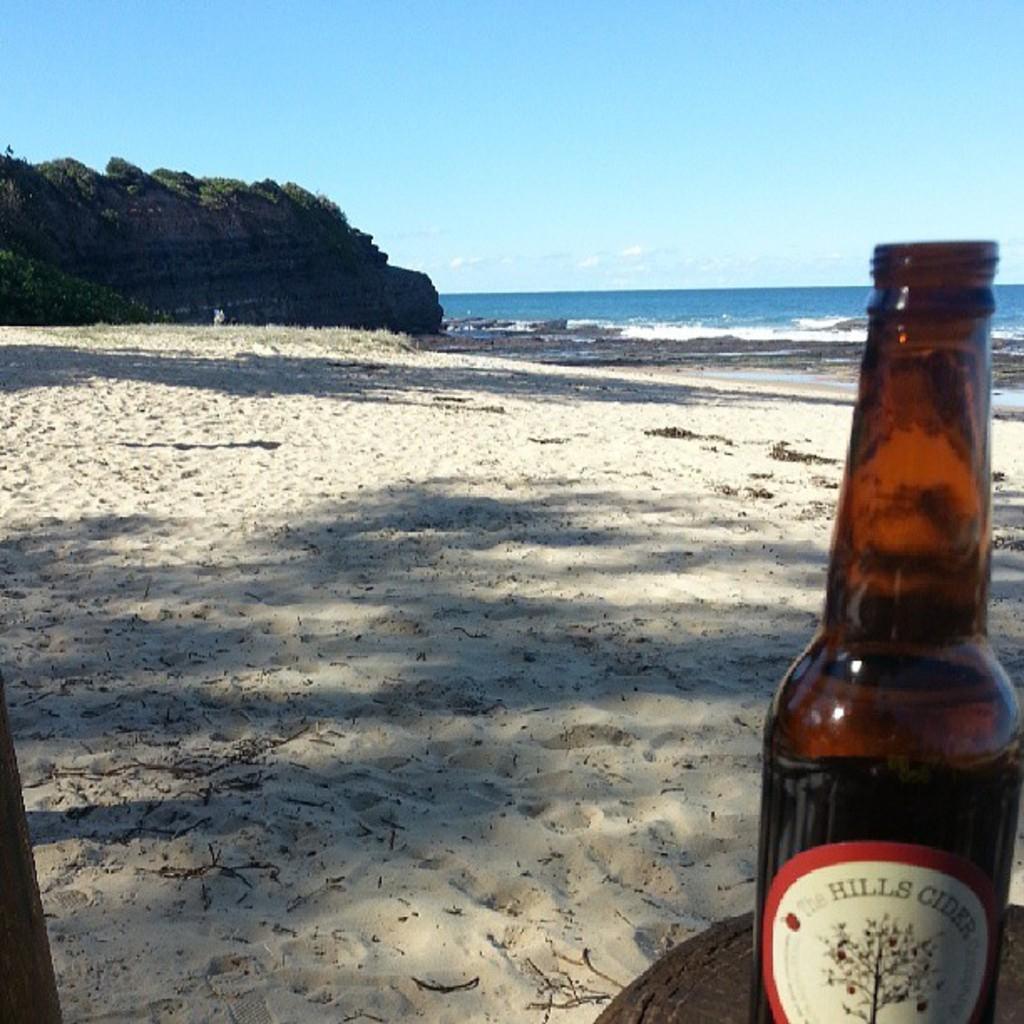Please provide a concise description of this image. In this image I can see a bottle, sand, water and clear view of sky. 